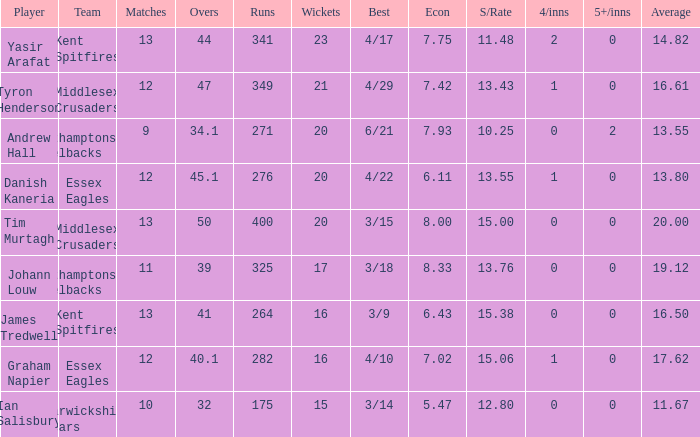Could you parse the entire table? {'header': ['Player', 'Team', 'Matches', 'Overs', 'Runs', 'Wickets', 'Best', 'Econ', 'S/Rate', '4/inns', '5+/inns', 'Average'], 'rows': [['Yasir Arafat', 'Kent Spitfires', '13', '44', '341', '23', '4/17', '7.75', '11.48', '2', '0', '14.82'], ['Tyron Henderson', 'Middlesex Crusaders', '12', '47', '349', '21', '4/29', '7.42', '13.43', '1', '0', '16.61'], ['Andrew Hall', 'Northamptonshire Steelbacks', '9', '34.1', '271', '20', '6/21', '7.93', '10.25', '0', '2', '13.55'], ['Danish Kaneria', 'Essex Eagles', '12', '45.1', '276', '20', '4/22', '6.11', '13.55', '1', '0', '13.80'], ['Tim Murtagh', 'Middlesex Crusaders', '13', '50', '400', '20', '3/15', '8.00', '15.00', '0', '0', '20.00'], ['Johann Louw', 'Northamptonshire Steelbacks', '11', '39', '325', '17', '3/18', '8.33', '13.76', '0', '0', '19.12'], ['James Tredwell', 'Kent Spitfires', '13', '41', '264', '16', '3/9', '6.43', '15.38', '0', '0', '16.50'], ['Graham Napier', 'Essex Eagles', '12', '40.1', '282', '16', '4/10', '7.02', '15.06', '1', '0', '17.62'], ['Ian Salisbury', 'Warwickshire Bears', '10', '32', '175', '15', '3/14', '5.47', '12.80', '0', '0', '11.67']]} Name the most wickets for best is 4/22 20.0. 